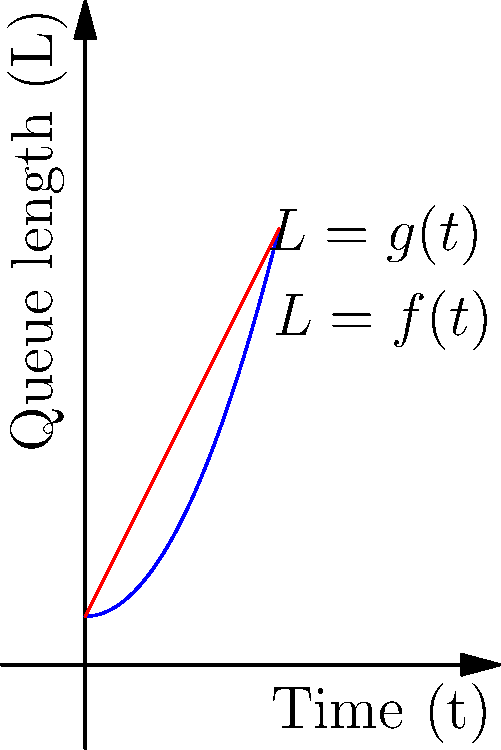As a club manager, you're analyzing the queue dynamics during peak hours. The graph shows the relationship between time (t) and queue length (L). The blue curve represents the actual wait time function $L = f(t) = 0.5t^2 + 1$, while the red line is a linear approximation $L = g(t) = 2t + 1$. Using the calculus of variations, determine the time $t^*$ at which the difference between the actual wait time and its linear approximation is maximized. To solve this problem, we'll follow these steps:

1) The difference between the actual wait time and its linear approximation is given by:
   $$h(t) = f(t) - g(t) = (0.5t^2 + 1) - (2t + 1) = 0.5t^2 - 2t$$

2) To find the maximum difference, we need to find where the derivative of h(t) is zero:
   $$h'(t) = t - 2$$

3) Set h'(t) = 0 and solve for t:
   $$t - 2 = 0$$
   $$t = 2$$

4) To confirm this is a maximum, we can check the second derivative:
   $$h''(t) = 1$$
   Since h''(t) is positive, t = 2 indeed gives a maximum.

5) Therefore, the time $t^*$ at which the difference between the actual wait time and its linear approximation is maximized is 2.

This result suggests that at t = 2, the actual queue length deviates most from what a linear model would predict, which is crucial information for managing peak hour operations.
Answer: $t^* = 2$ 